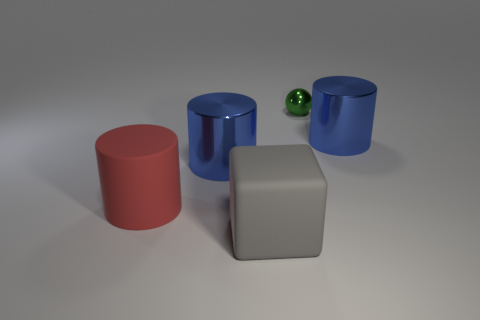There is a blue object on the right side of the green ball; does it have the same size as the matte block?
Offer a terse response. Yes. There is a large blue thing in front of the large blue cylinder behind the large blue metal thing that is to the left of the tiny green shiny thing; what is its shape?
Keep it short and to the point. Cylinder. What number of objects are either gray objects or big blue things behind the big gray block?
Your answer should be compact. 3. There is a blue metallic cylinder that is left of the tiny sphere; how big is it?
Your answer should be compact. Large. Is the sphere made of the same material as the big blue object on the right side of the gray matte cube?
Give a very brief answer. Yes. There is a rubber thing on the right side of the large matte thing to the left of the large gray block; how many metal balls are left of it?
Offer a terse response. 0. How many green objects are either small metal things or tiny cubes?
Make the answer very short. 1. What is the shape of the blue metallic object that is left of the rubber block?
Provide a short and direct response. Cylinder. There is a matte thing that is the same size as the cube; what is its color?
Keep it short and to the point. Red. There is a small green object; does it have the same shape as the big blue shiny object left of the green sphere?
Offer a very short reply. No. 